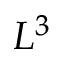Convert formula to latex. <formula><loc_0><loc_0><loc_500><loc_500>L ^ { 3 }</formula> 